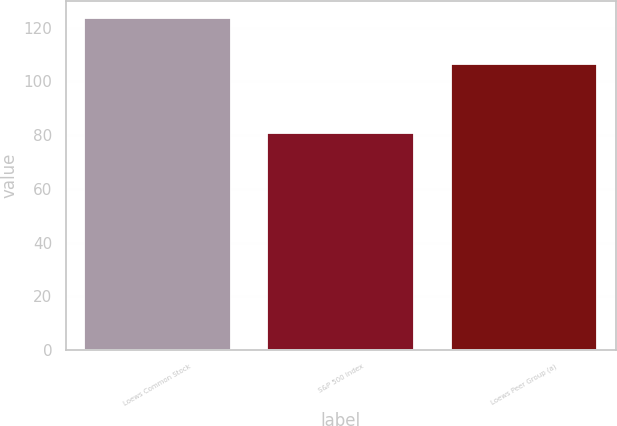Convert chart to OTSL. <chart><loc_0><loc_0><loc_500><loc_500><bar_chart><fcel>Loews Common Stock<fcel>S&P 500 Index<fcel>Loews Peer Group (a)<nl><fcel>123.7<fcel>80.74<fcel>106.3<nl></chart> 